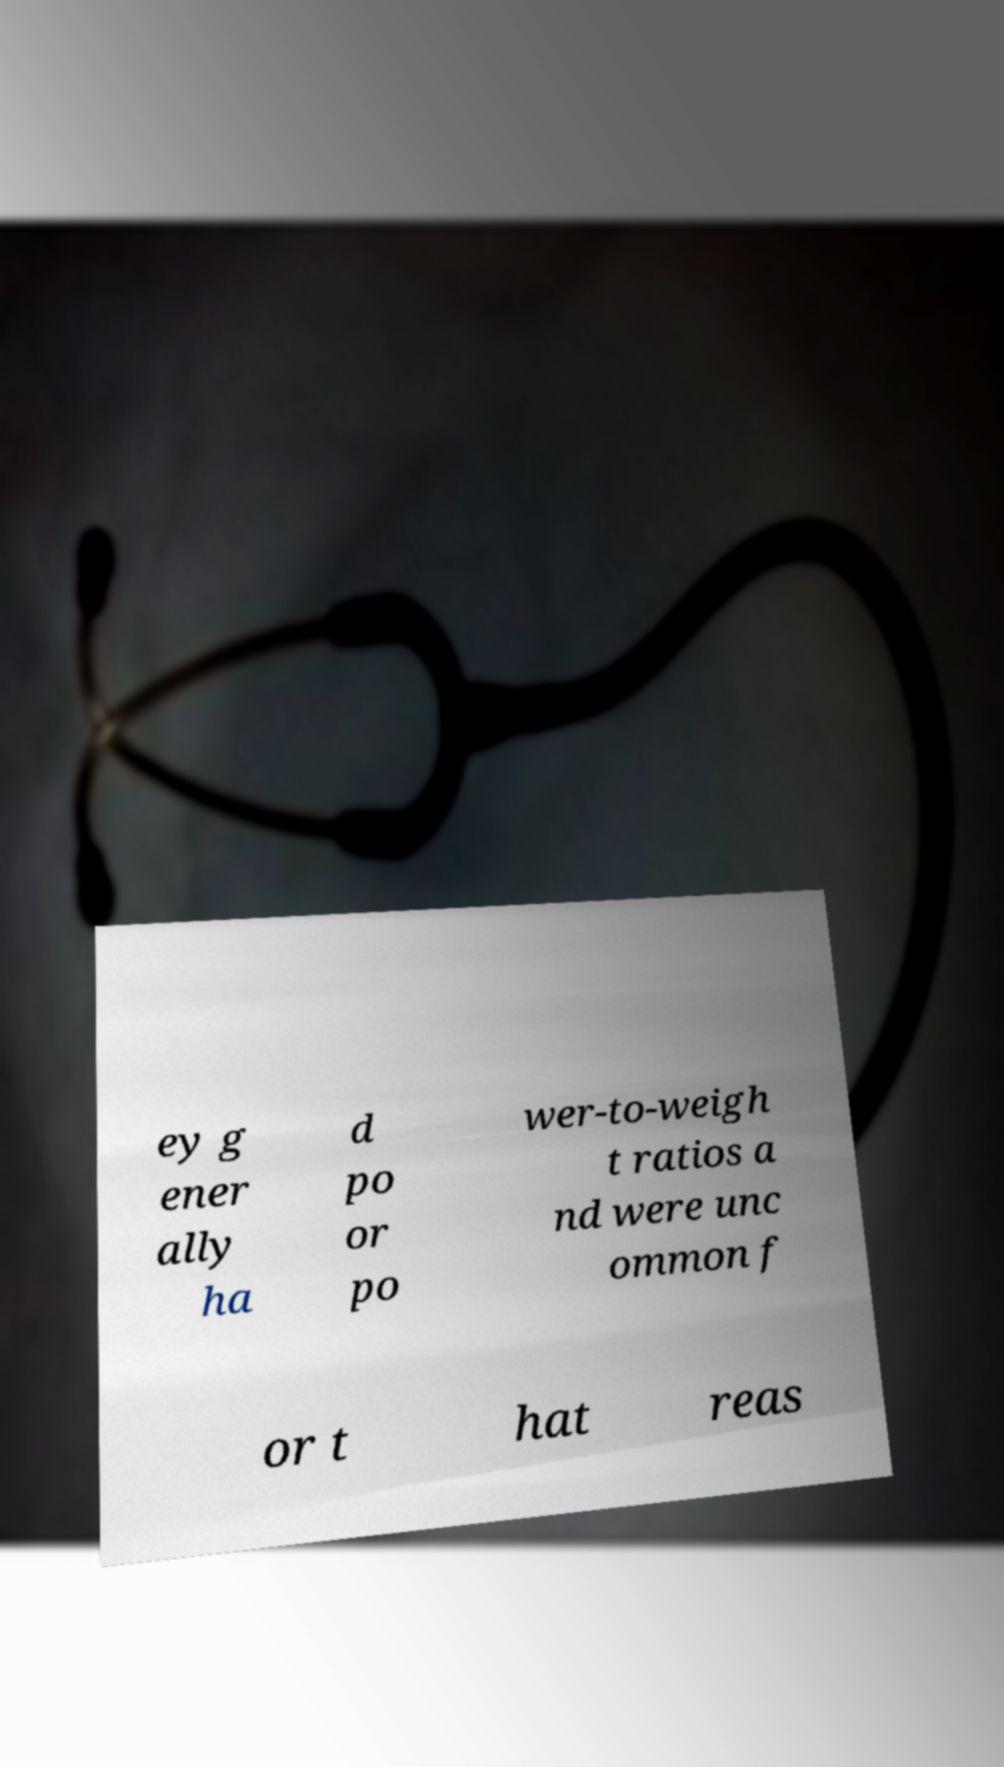There's text embedded in this image that I need extracted. Can you transcribe it verbatim? ey g ener ally ha d po or po wer-to-weigh t ratios a nd were unc ommon f or t hat reas 